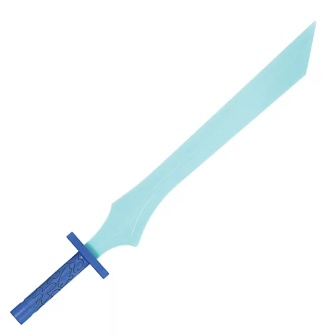Can you create a short story involving this sword? In the mystical land of Lumaria, young Elara discovered an ancient sword buried beneath the roots of an old oak tree. The sword, with its radiant blue blade and intricately designed pommel, felt destined for her hand. As she drew the sword, a surge of energy coursed through her, and she knew this relic held untold powers. Elara embarked on a quest to defend her village from an encroaching shadow, wielding the sword’s mystical abilities to banish darkness and bring peace to the land. 